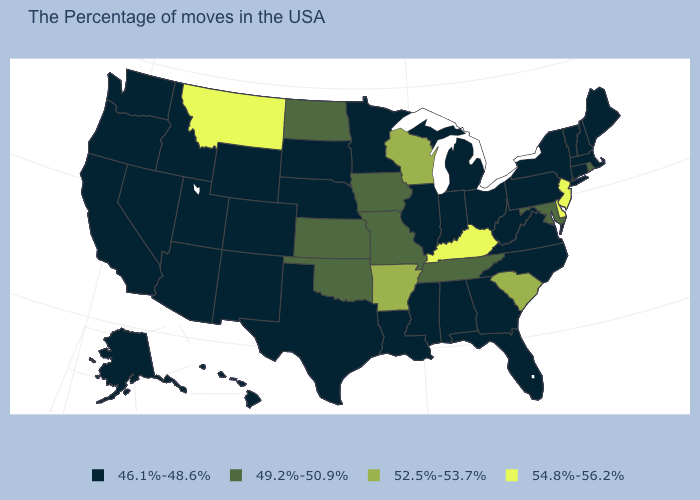What is the highest value in the USA?
Short answer required. 54.8%-56.2%. Which states have the highest value in the USA?
Keep it brief. New Jersey, Delaware, Kentucky, Montana. Which states have the lowest value in the USA?
Keep it brief. Maine, Massachusetts, New Hampshire, Vermont, Connecticut, New York, Pennsylvania, Virginia, North Carolina, West Virginia, Ohio, Florida, Georgia, Michigan, Indiana, Alabama, Illinois, Mississippi, Louisiana, Minnesota, Nebraska, Texas, South Dakota, Wyoming, Colorado, New Mexico, Utah, Arizona, Idaho, Nevada, California, Washington, Oregon, Alaska, Hawaii. What is the value of Alaska?
Answer briefly. 46.1%-48.6%. What is the value of South Dakota?
Quick response, please. 46.1%-48.6%. What is the lowest value in the USA?
Keep it brief. 46.1%-48.6%. What is the value of Tennessee?
Write a very short answer. 49.2%-50.9%. Name the states that have a value in the range 46.1%-48.6%?
Concise answer only. Maine, Massachusetts, New Hampshire, Vermont, Connecticut, New York, Pennsylvania, Virginia, North Carolina, West Virginia, Ohio, Florida, Georgia, Michigan, Indiana, Alabama, Illinois, Mississippi, Louisiana, Minnesota, Nebraska, Texas, South Dakota, Wyoming, Colorado, New Mexico, Utah, Arizona, Idaho, Nevada, California, Washington, Oregon, Alaska, Hawaii. Name the states that have a value in the range 46.1%-48.6%?
Keep it brief. Maine, Massachusetts, New Hampshire, Vermont, Connecticut, New York, Pennsylvania, Virginia, North Carolina, West Virginia, Ohio, Florida, Georgia, Michigan, Indiana, Alabama, Illinois, Mississippi, Louisiana, Minnesota, Nebraska, Texas, South Dakota, Wyoming, Colorado, New Mexico, Utah, Arizona, Idaho, Nevada, California, Washington, Oregon, Alaska, Hawaii. What is the value of Arkansas?
Keep it brief. 52.5%-53.7%. What is the highest value in the USA?
Give a very brief answer. 54.8%-56.2%. Among the states that border Delaware , does New Jersey have the highest value?
Give a very brief answer. Yes. What is the lowest value in the USA?
Concise answer only. 46.1%-48.6%. Which states have the highest value in the USA?
Write a very short answer. New Jersey, Delaware, Kentucky, Montana. Does West Virginia have the lowest value in the South?
Be succinct. Yes. 